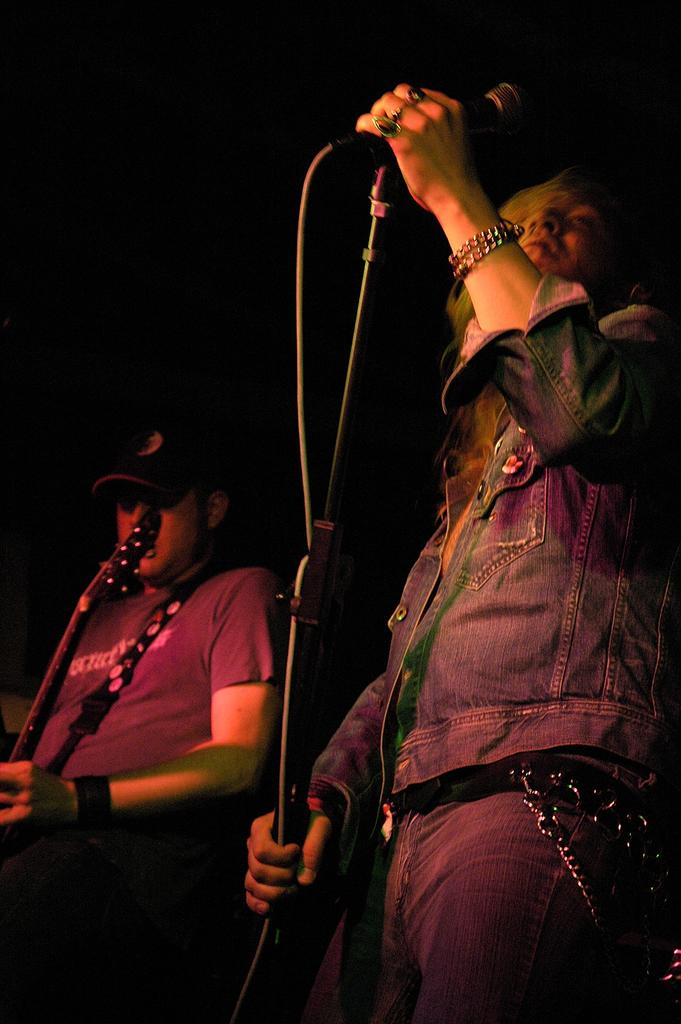How many people are in the image? There are two persons in the image. What objects are in front of the persons? There are two microphones in front of the persons. What can be observed about the background of the image? The background of the image is dark. What type of camp can be seen in the background of the image? There is no camp present in the image; the background is dark. How does the brake work on the microphones in the image? There are no brakes on the microphones in the image; they are simply objects for amplifying sound. 